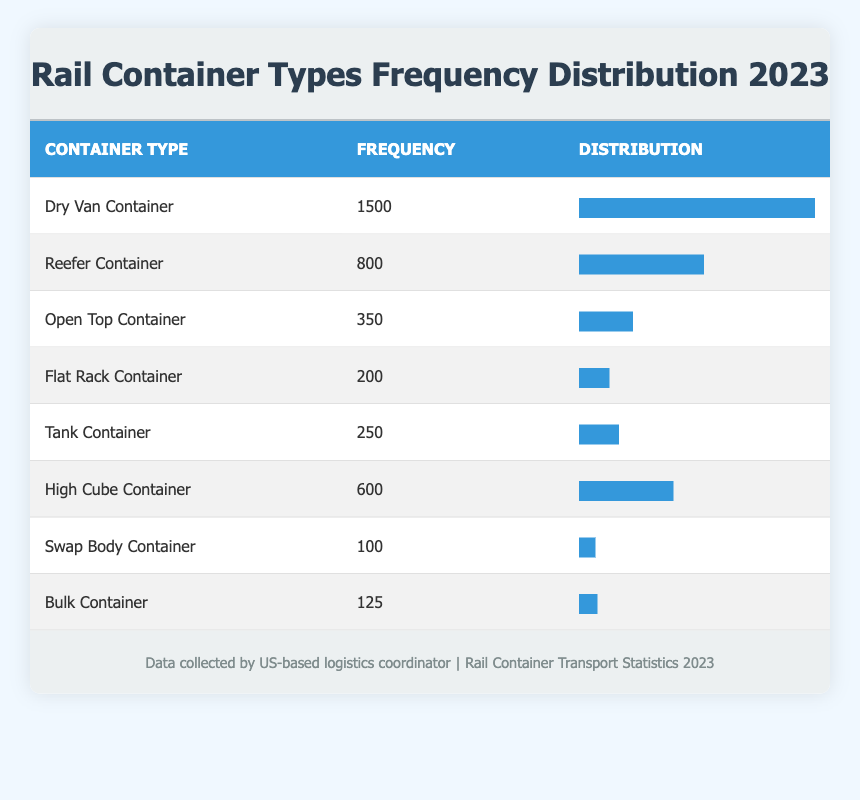What is the most frequently transported container type via rail in 2023? The most frequently transported container type is found by identifying the highest frequency value in the table. According to the data, the "Dry Van Container" has the highest frequency of 1500, making it the most frequently transported container type.
Answer: Dry Van Container How many Reefer Containers were transported via rail in 2023? The frequency of Reefer Containers can be directly read from the table. It shows that 800 Reefer Containers were transported via rail in 2023.
Answer: 800 What is the total frequency of Open Top and Flat Rack Containers combined? To find the total frequency of Open Top and Flat Rack Containers, I sum the individual frequencies given in the table: 350 (Open Top) + 200 (Flat Rack) = 550.
Answer: 550 Is the frequency of Tank Containers greater than the frequency of Bulk Containers? To answer this, I compare the frequencies listed in the table: Tank Containers have a frequency of 250, while Bulk Containers have a frequency of 125. Since 250 is greater than 125, the answer is yes.
Answer: Yes What percentage of the total containers transported were High Cube Containers? First, I need to calculate the total frequency of all container types. Summing them gives: 1500 + 800 + 350 + 200 + 250 + 600 + 100 + 125 = 3925. The frequency of High Cube Containers is 600. The percentage can be calculated as (600/3925) * 100, which equals approximately 15.3%.
Answer: 15.3% Which container type has the lowest frequency in 2023? By quickly reviewing the frequency values in the table, I see that the "Swap Body Container" has the lowest frequency, recorded at 100.
Answer: Swap Body Container How many more Dry Van Containers were transported than High Cube Containers? I find the frequencies for each container type: Dry Van Containers are 1500 and High Cube Containers are 600. The difference is calculated as 1500 - 600 = 900.
Answer: 900 What is the average frequency of all the container types listed? To find the average frequency, I first calculate the total frequency (3925 from the previous calculation) and divide it by the number of container types, which is 8. Thus, the average frequency is 3925 / 8 = 490.625.
Answer: 490.625 How many container types have a frequency of less than 300? I analyze the frequencies of all the container types in the table: Open Top (350), Flat Rack (200), Tank (250), Swap Body (100), and Bulk (125). The only ones that have a frequency less than 300 are Flat Rack, Tank, Swap Body, and Bulk, totaling four container types.
Answer: 4 